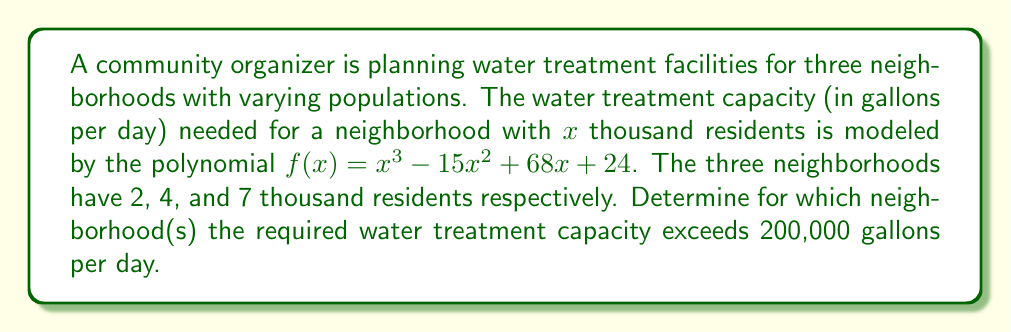Can you answer this question? To solve this problem, we need to determine for which values of $x$ the inequality $f(x) > 200$ holds true, where $f(x) = x^3 - 15x^2 + 68x + 24$ and $x$ represents the population in thousands.

Step 1: Set up the inequality
$$x^3 - 15x^2 + 68x + 24 > 200$$

Step 2: Rearrange the inequality
$$x^3 - 15x^2 + 68x - 176 > 0$$

Step 3: Factor the left side of the inequality
$$(x - 4)(x - 11)(x + 1) > 0$$

Step 4: Determine the critical points
The critical points are $x = -1$, $x = 4$, and $x = 11$

Step 5: Create a sign chart to determine where the inequality is positive
(-∞, -1): (-)(-)(-)  = -
(-1, 4):  (+)(-)(-) = +
(4, 11):  (+)(+)(-) = -
(11, ∞):  (+)(+)(+) = +

Step 6: Interpret the results
The inequality is positive when $-1 < x < 4$ or $x > 11$

Step 7: Check the given population values
- For 2,000 residents ($x = 2$): $-1 < 2 < 4$, so the inequality holds
- For 4,000 residents ($x = 4$): This is a critical point, so we need to check the value
  $f(4) = 4^3 - 15(4^2) + 68(4) + 24 = 64 - 240 + 272 + 24 = 120$ thousand gallons, which is less than 200
- For 7,000 residents ($x = 7$): $4 < 7 < 11$, so the inequality does not hold

Step 8: Conclusion
Only the neighborhood with 2,000 residents requires a water treatment capacity exceeding 200,000 gallons per day.
Answer: The neighborhood with 2,000 residents requires a water treatment capacity exceeding 200,000 gallons per day. 